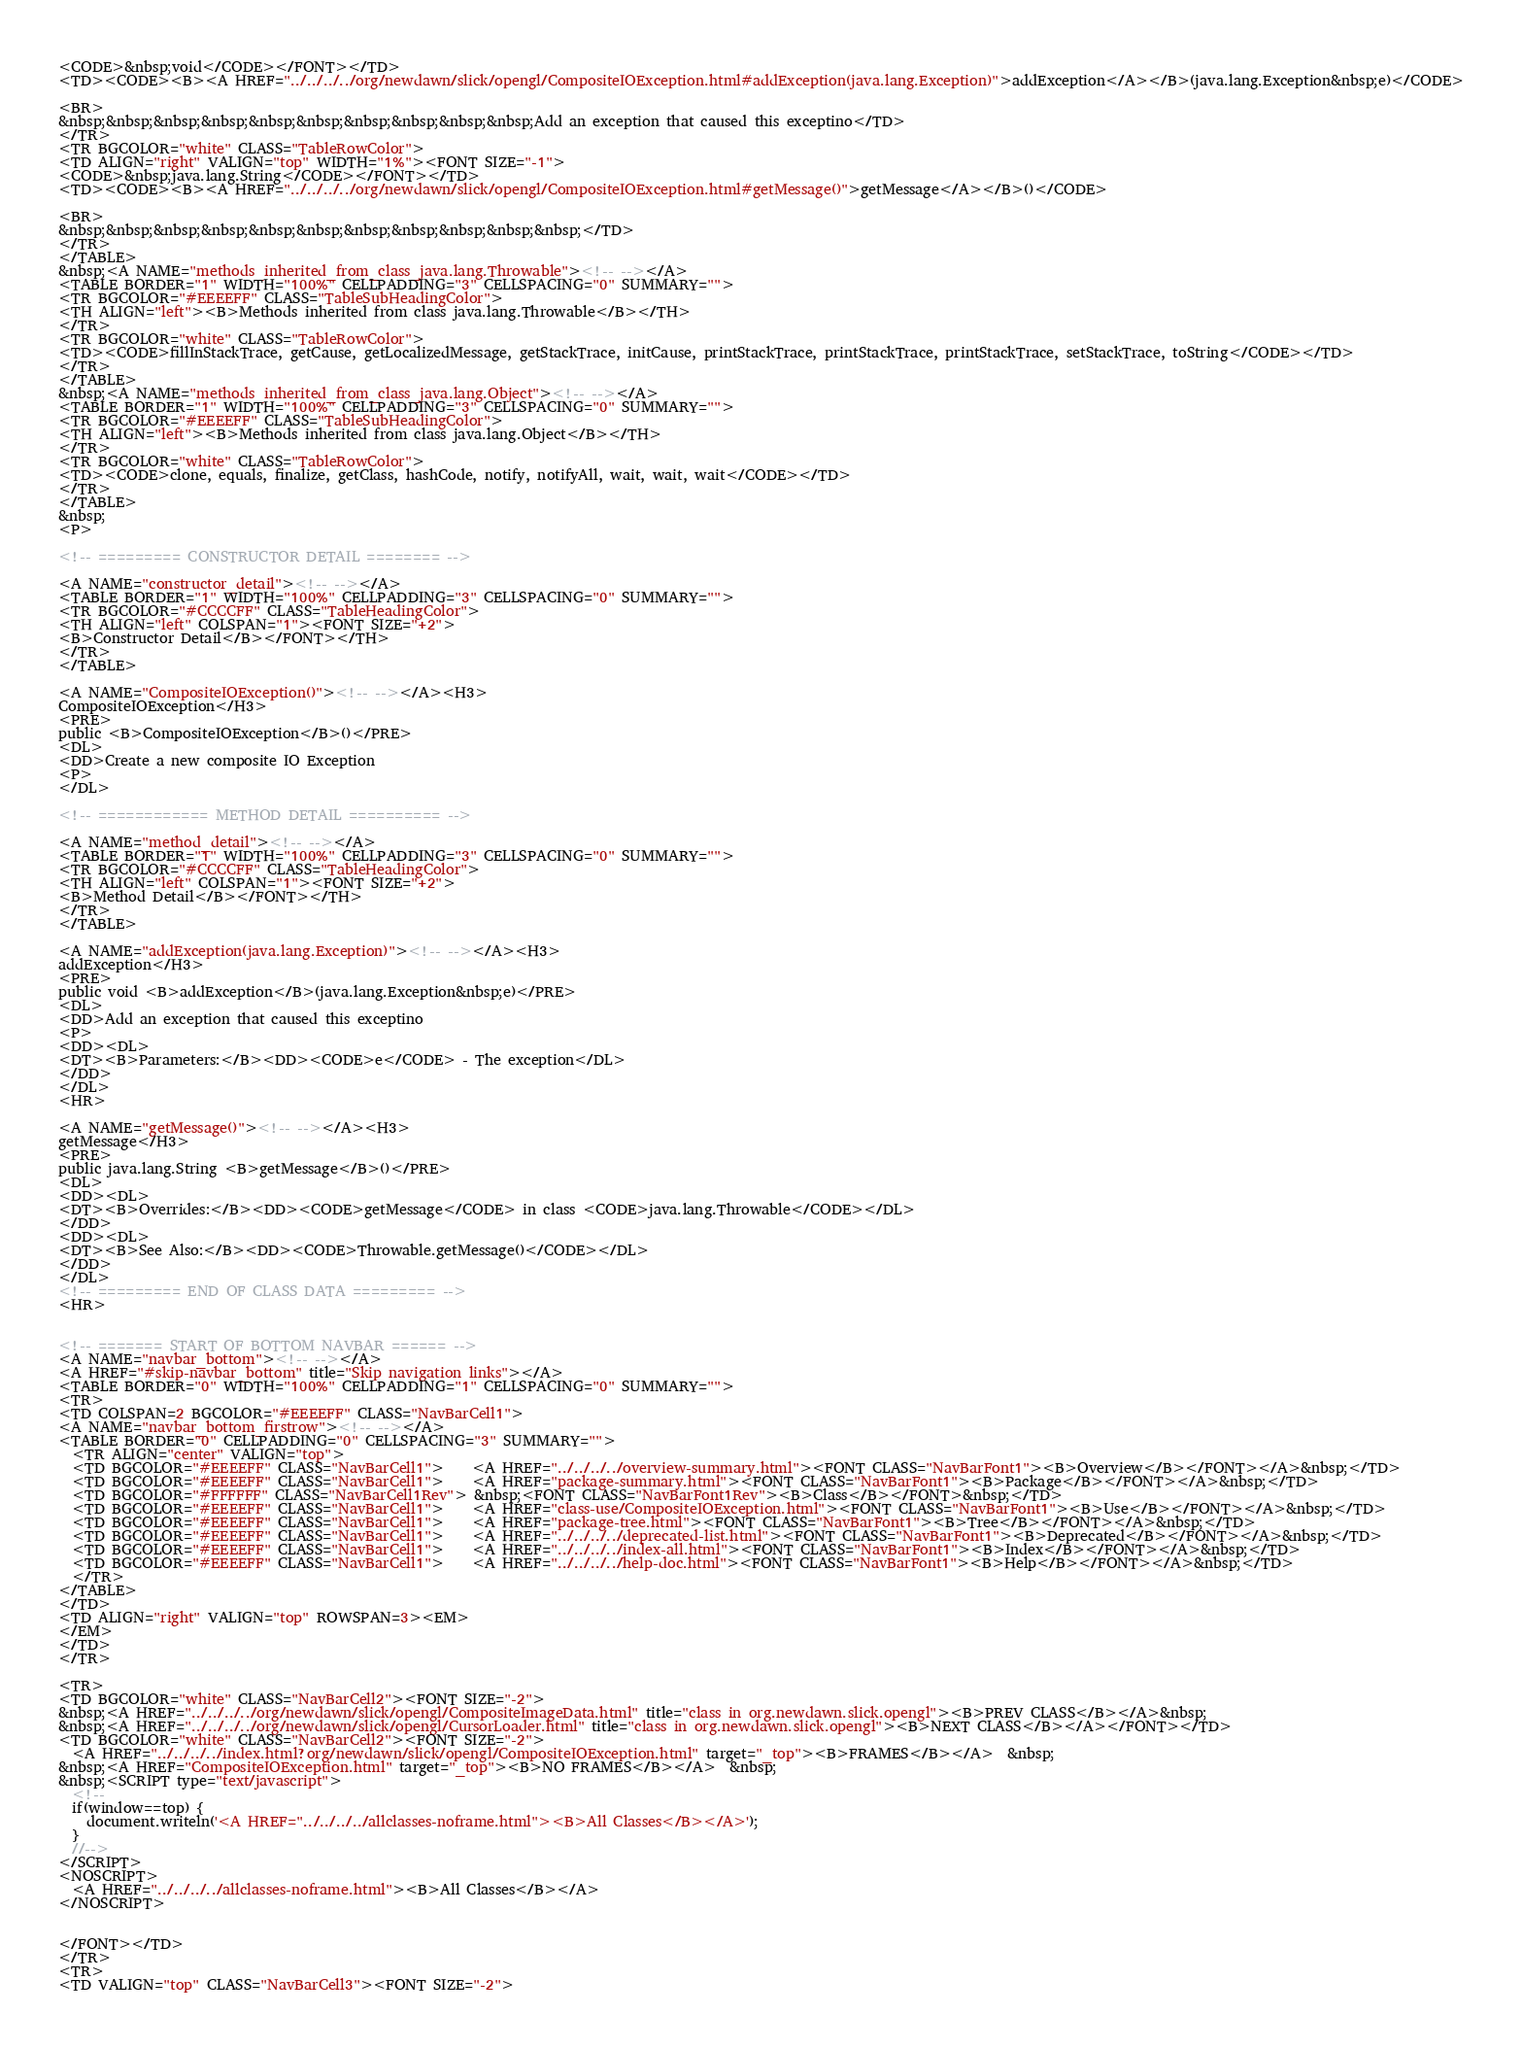Convert code to text. <code><loc_0><loc_0><loc_500><loc_500><_HTML_><CODE>&nbsp;void</CODE></FONT></TD>
<TD><CODE><B><A HREF="../../../../org/newdawn/slick/opengl/CompositeIOException.html#addException(java.lang.Exception)">addException</A></B>(java.lang.Exception&nbsp;e)</CODE>

<BR>
&nbsp;&nbsp;&nbsp;&nbsp;&nbsp;&nbsp;&nbsp;&nbsp;&nbsp;&nbsp;Add an exception that caused this exceptino</TD>
</TR>
<TR BGCOLOR="white" CLASS="TableRowColor">
<TD ALIGN="right" VALIGN="top" WIDTH="1%"><FONT SIZE="-1">
<CODE>&nbsp;java.lang.String</CODE></FONT></TD>
<TD><CODE><B><A HREF="../../../../org/newdawn/slick/opengl/CompositeIOException.html#getMessage()">getMessage</A></B>()</CODE>

<BR>
&nbsp;&nbsp;&nbsp;&nbsp;&nbsp;&nbsp;&nbsp;&nbsp;&nbsp;&nbsp;&nbsp;</TD>
</TR>
</TABLE>
&nbsp;<A NAME="methods_inherited_from_class_java.lang.Throwable"><!-- --></A>
<TABLE BORDER="1" WIDTH="100%" CELLPADDING="3" CELLSPACING="0" SUMMARY="">
<TR BGCOLOR="#EEEEFF" CLASS="TableSubHeadingColor">
<TH ALIGN="left"><B>Methods inherited from class java.lang.Throwable</B></TH>
</TR>
<TR BGCOLOR="white" CLASS="TableRowColor">
<TD><CODE>fillInStackTrace, getCause, getLocalizedMessage, getStackTrace, initCause, printStackTrace, printStackTrace, printStackTrace, setStackTrace, toString</CODE></TD>
</TR>
</TABLE>
&nbsp;<A NAME="methods_inherited_from_class_java.lang.Object"><!-- --></A>
<TABLE BORDER="1" WIDTH="100%" CELLPADDING="3" CELLSPACING="0" SUMMARY="">
<TR BGCOLOR="#EEEEFF" CLASS="TableSubHeadingColor">
<TH ALIGN="left"><B>Methods inherited from class java.lang.Object</B></TH>
</TR>
<TR BGCOLOR="white" CLASS="TableRowColor">
<TD><CODE>clone, equals, finalize, getClass, hashCode, notify, notifyAll, wait, wait, wait</CODE></TD>
</TR>
</TABLE>
&nbsp;
<P>

<!-- ========= CONSTRUCTOR DETAIL ======== -->

<A NAME="constructor_detail"><!-- --></A>
<TABLE BORDER="1" WIDTH="100%" CELLPADDING="3" CELLSPACING="0" SUMMARY="">
<TR BGCOLOR="#CCCCFF" CLASS="TableHeadingColor">
<TH ALIGN="left" COLSPAN="1"><FONT SIZE="+2">
<B>Constructor Detail</B></FONT></TH>
</TR>
</TABLE>

<A NAME="CompositeIOException()"><!-- --></A><H3>
CompositeIOException</H3>
<PRE>
public <B>CompositeIOException</B>()</PRE>
<DL>
<DD>Create a new composite IO Exception
<P>
</DL>

<!-- ============ METHOD DETAIL ========== -->

<A NAME="method_detail"><!-- --></A>
<TABLE BORDER="1" WIDTH="100%" CELLPADDING="3" CELLSPACING="0" SUMMARY="">
<TR BGCOLOR="#CCCCFF" CLASS="TableHeadingColor">
<TH ALIGN="left" COLSPAN="1"><FONT SIZE="+2">
<B>Method Detail</B></FONT></TH>
</TR>
</TABLE>

<A NAME="addException(java.lang.Exception)"><!-- --></A><H3>
addException</H3>
<PRE>
public void <B>addException</B>(java.lang.Exception&nbsp;e)</PRE>
<DL>
<DD>Add an exception that caused this exceptino
<P>
<DD><DL>
<DT><B>Parameters:</B><DD><CODE>e</CODE> - The exception</DL>
</DD>
</DL>
<HR>

<A NAME="getMessage()"><!-- --></A><H3>
getMessage</H3>
<PRE>
public java.lang.String <B>getMessage</B>()</PRE>
<DL>
<DD><DL>
<DT><B>Overrides:</B><DD><CODE>getMessage</CODE> in class <CODE>java.lang.Throwable</CODE></DL>
</DD>
<DD><DL>
<DT><B>See Also:</B><DD><CODE>Throwable.getMessage()</CODE></DL>
</DD>
</DL>
<!-- ========= END OF CLASS DATA ========= -->
<HR>


<!-- ======= START OF BOTTOM NAVBAR ====== -->
<A NAME="navbar_bottom"><!-- --></A>
<A HREF="#skip-navbar_bottom" title="Skip navigation links"></A>
<TABLE BORDER="0" WIDTH="100%" CELLPADDING="1" CELLSPACING="0" SUMMARY="">
<TR>
<TD COLSPAN=2 BGCOLOR="#EEEEFF" CLASS="NavBarCell1">
<A NAME="navbar_bottom_firstrow"><!-- --></A>
<TABLE BORDER="0" CELLPADDING="0" CELLSPACING="3" SUMMARY="">
  <TR ALIGN="center" VALIGN="top">
  <TD BGCOLOR="#EEEEFF" CLASS="NavBarCell1">    <A HREF="../../../../overview-summary.html"><FONT CLASS="NavBarFont1"><B>Overview</B></FONT></A>&nbsp;</TD>
  <TD BGCOLOR="#EEEEFF" CLASS="NavBarCell1">    <A HREF="package-summary.html"><FONT CLASS="NavBarFont1"><B>Package</B></FONT></A>&nbsp;</TD>
  <TD BGCOLOR="#FFFFFF" CLASS="NavBarCell1Rev"> &nbsp;<FONT CLASS="NavBarFont1Rev"><B>Class</B></FONT>&nbsp;</TD>
  <TD BGCOLOR="#EEEEFF" CLASS="NavBarCell1">    <A HREF="class-use/CompositeIOException.html"><FONT CLASS="NavBarFont1"><B>Use</B></FONT></A>&nbsp;</TD>
  <TD BGCOLOR="#EEEEFF" CLASS="NavBarCell1">    <A HREF="package-tree.html"><FONT CLASS="NavBarFont1"><B>Tree</B></FONT></A>&nbsp;</TD>
  <TD BGCOLOR="#EEEEFF" CLASS="NavBarCell1">    <A HREF="../../../../deprecated-list.html"><FONT CLASS="NavBarFont1"><B>Deprecated</B></FONT></A>&nbsp;</TD>
  <TD BGCOLOR="#EEEEFF" CLASS="NavBarCell1">    <A HREF="../../../../index-all.html"><FONT CLASS="NavBarFont1"><B>Index</B></FONT></A>&nbsp;</TD>
  <TD BGCOLOR="#EEEEFF" CLASS="NavBarCell1">    <A HREF="../../../../help-doc.html"><FONT CLASS="NavBarFont1"><B>Help</B></FONT></A>&nbsp;</TD>
  </TR>
</TABLE>
</TD>
<TD ALIGN="right" VALIGN="top" ROWSPAN=3><EM>
</EM>
</TD>
</TR>

<TR>
<TD BGCOLOR="white" CLASS="NavBarCell2"><FONT SIZE="-2">
&nbsp;<A HREF="../../../../org/newdawn/slick/opengl/CompositeImageData.html" title="class in org.newdawn.slick.opengl"><B>PREV CLASS</B></A>&nbsp;
&nbsp;<A HREF="../../../../org/newdawn/slick/opengl/CursorLoader.html" title="class in org.newdawn.slick.opengl"><B>NEXT CLASS</B></A></FONT></TD>
<TD BGCOLOR="white" CLASS="NavBarCell2"><FONT SIZE="-2">
  <A HREF="../../../../index.html?org/newdawn/slick/opengl/CompositeIOException.html" target="_top"><B>FRAMES</B></A>  &nbsp;
&nbsp;<A HREF="CompositeIOException.html" target="_top"><B>NO FRAMES</B></A>  &nbsp;
&nbsp;<SCRIPT type="text/javascript">
  <!--
  if(window==top) {
    document.writeln('<A HREF="../../../../allclasses-noframe.html"><B>All Classes</B></A>');
  }
  //-->
</SCRIPT>
<NOSCRIPT>
  <A HREF="../../../../allclasses-noframe.html"><B>All Classes</B></A>
</NOSCRIPT>


</FONT></TD>
</TR>
<TR>
<TD VALIGN="top" CLASS="NavBarCell3"><FONT SIZE="-2"></code> 